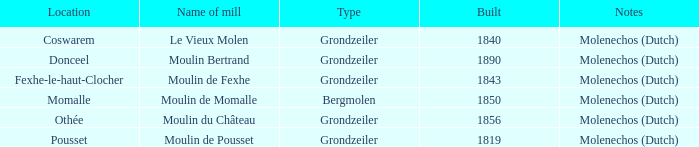What is year Built of the Moulin de Momalle Mill? 1850.0. 